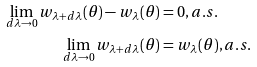<formula> <loc_0><loc_0><loc_500><loc_500>\lim _ { d \lambda \rightarrow 0 } w _ { \lambda + d \lambda } ( \theta ) - w _ { \lambda } ( \theta ) & = 0 , a . s . \\ \lim _ { d \lambda \rightarrow 0 } w _ { \lambda + d \lambda } ( \theta ) & = w _ { \lambda } ( \theta ) , a . s .</formula> 